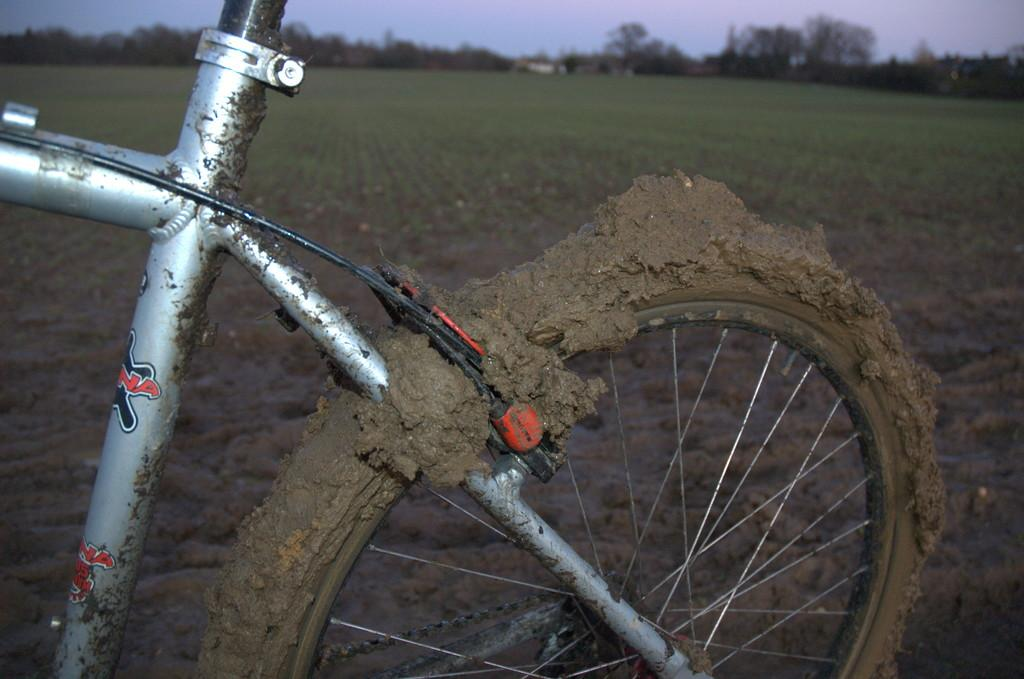What is the main subject of the image? The main subject of the image is a bicycle. How does the bicycle appear in the image? The bicycle is mud clogged and silver in color. What can be seen in the background of the image? There are farm lands, trees, and a clear sky in the background of the image. What type of rail system is visible in the image? There is no rail system present in the image; it features a mud clogged silver bicycle and a background with farm lands, trees, and a clear sky. What story is being told in the image? The image does not depict a story; it is a photograph of a mud clogged silver bicycle with a background of farm lands, trees, and a clear sky. 